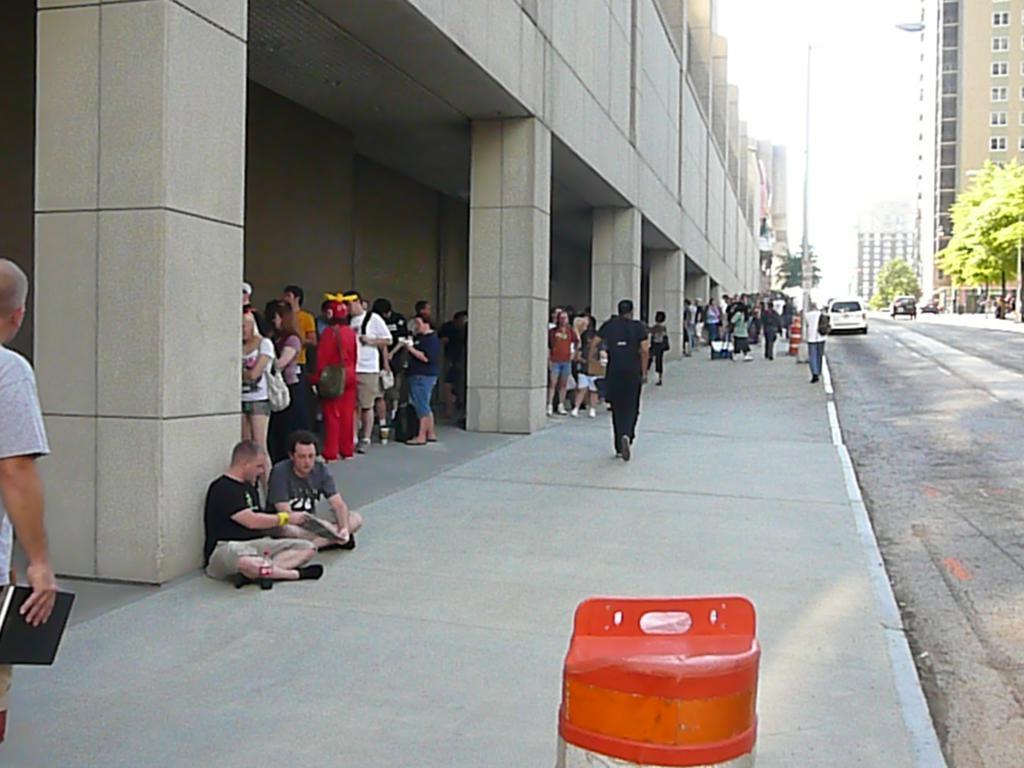Please provide a concise description of this image. In the foreground, I can see an object, crowd and vehicles on the road. In the background, I can see buildings, trees, fence, poles and the sky. This picture might be taken in a day. 